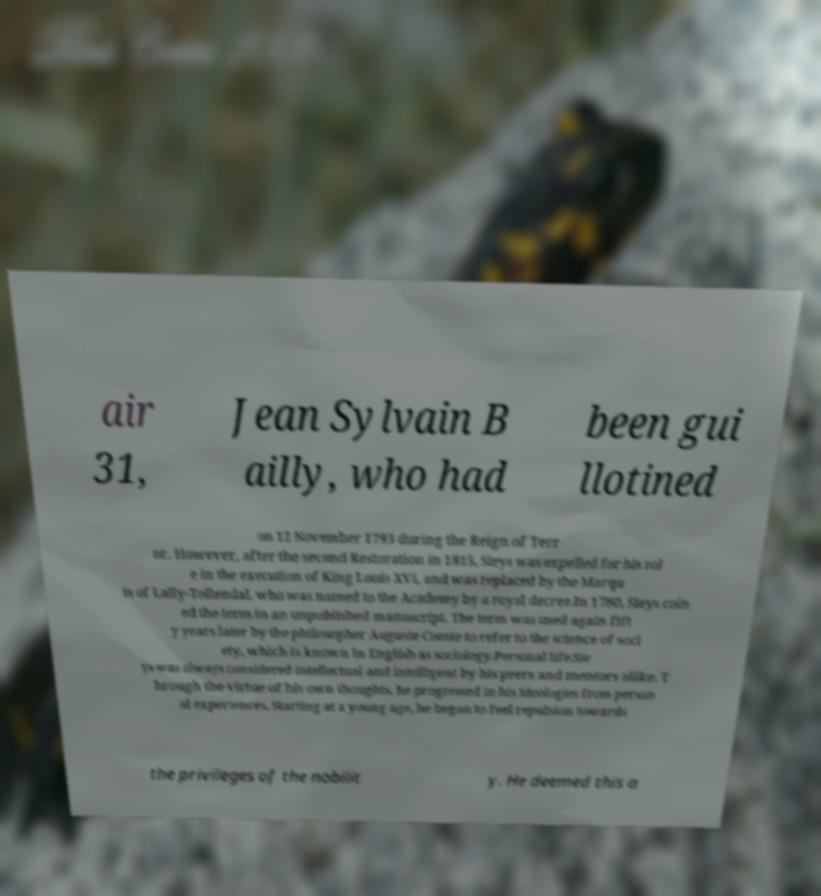Could you extract and type out the text from this image? air 31, Jean Sylvain B ailly, who had been gui llotined on 12 November 1793 during the Reign of Terr or. However, after the second Restoration in 1815, Sieys was expelled for his rol e in the execution of King Louis XVI, and was replaced by the Marqu is of Lally-Tollendal, who was named to the Academy by a royal decree.In 1780, Sieys coin ed the term in an unpublished manuscript. The term was used again fift y years later by the philosopher Auguste Comte to refer to the science of soci ety, which is known in English as sociology.Personal life.Sie ys was always considered intellectual and intelligent by his peers and mentors alike. T hrough the virtue of his own thoughts, he progressed in his ideologies from person al experiences. Starting at a young age, he began to feel repulsion towards the privileges of the nobilit y. He deemed this a 